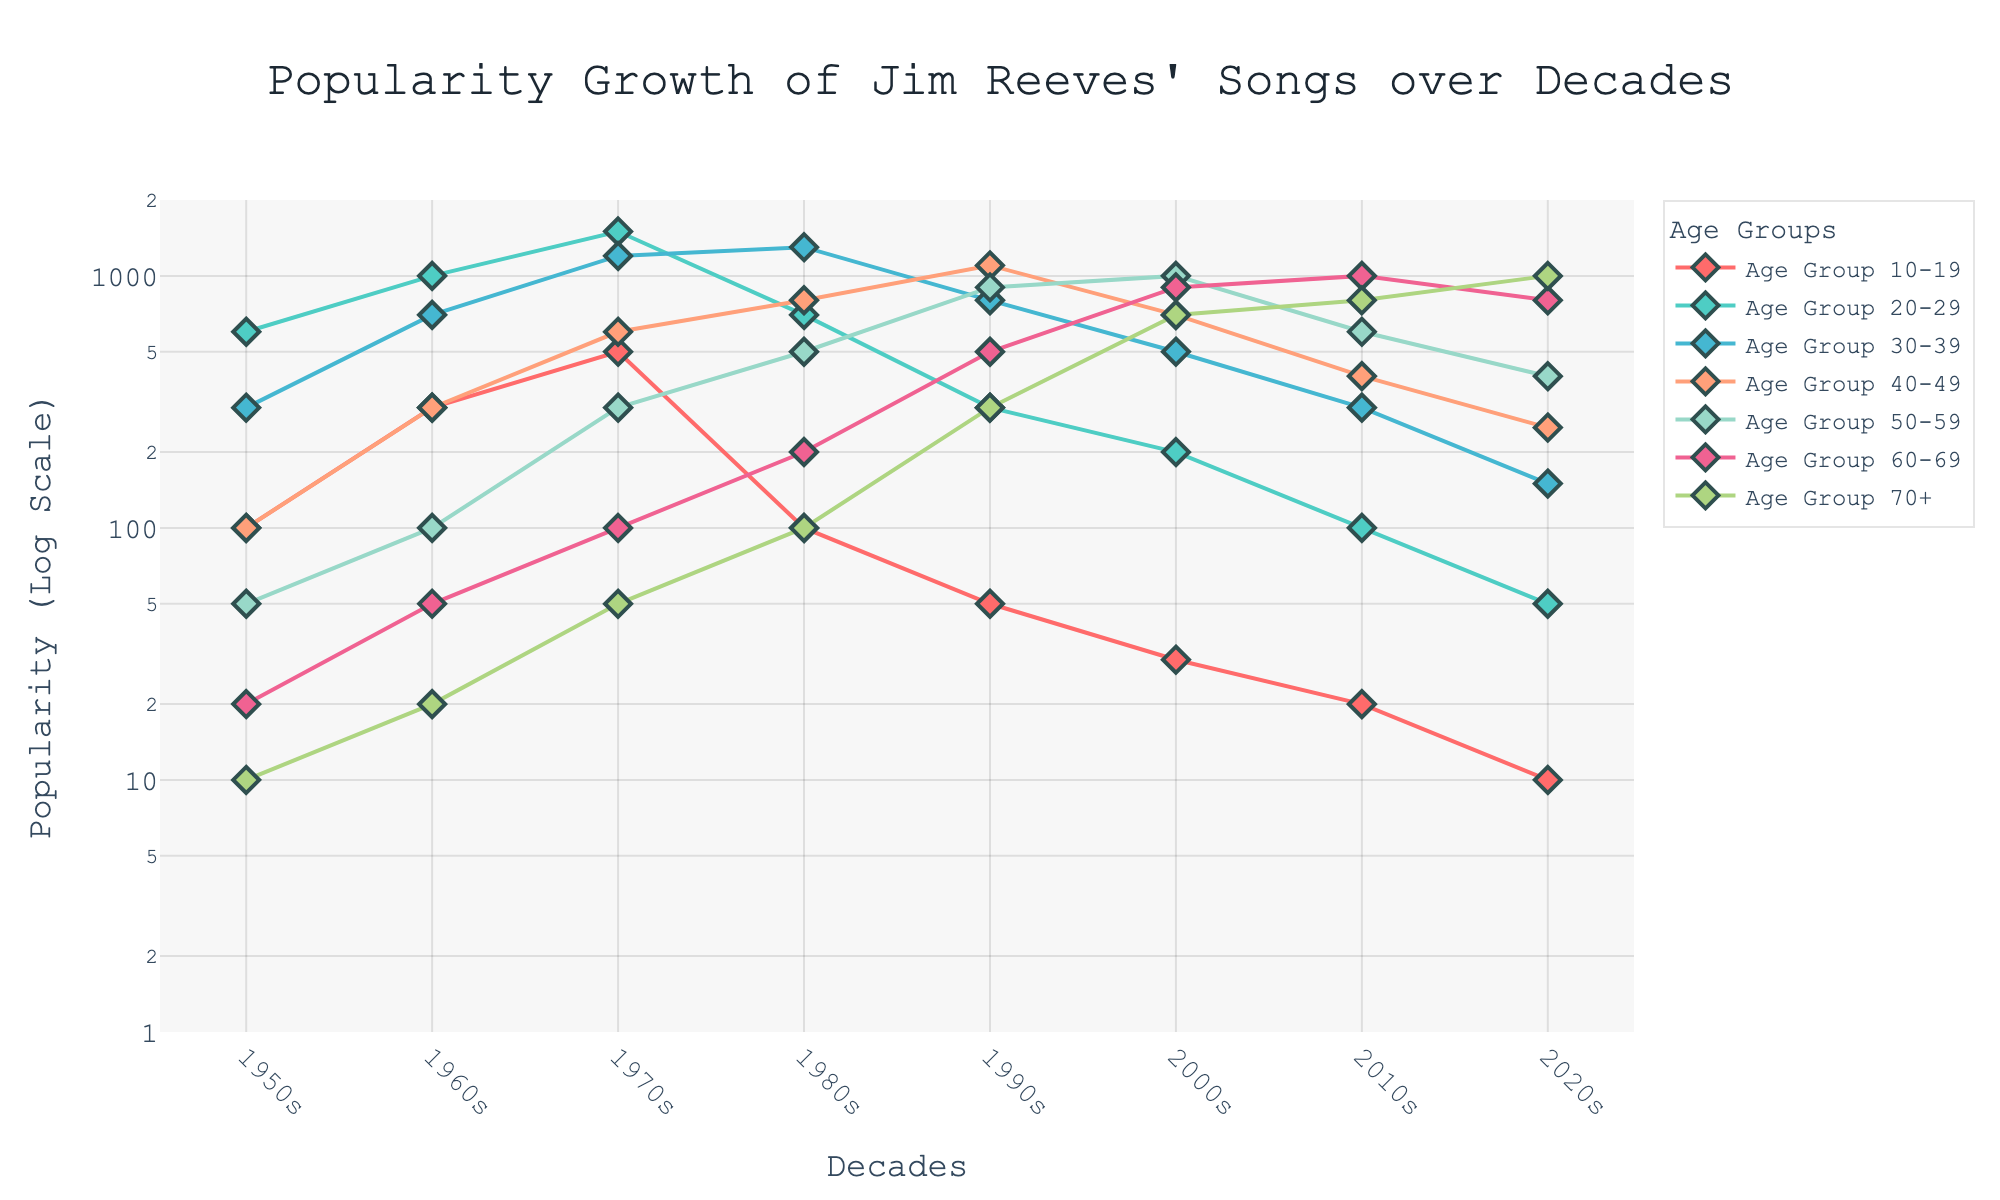What is the title of the plot? The title appears at the top of the plot and reads: "Popularity Growth of Jim Reeves' Songs over Decades".
Answer: Popularity Growth of Jim Reeves' Songs over Decades Which age group has the highest popularity in the 1960s? To find the highest popularity in the 1960s, look at the 1960s row and find the maximum value. It’s in the Age Group 20-29 with a value of 1000.
Answer: Age Group 20-29 How does the popularity trend for Age Group 40-49 change over the decades? Starting from the 1950s, the popularity values are 100, 300, 600, 800, 1100, 700, 400, and 250, initially increasing, peaking in the 1990s, and then gradually decreasing.
Answer: Increases, peaks in 1990s, then decreases Which age group shows the most consistent increase in popularity? By examining the trends for each age group over the decades, Age Group 60-69 consistently increases, with popularity values going from 20 in the 1950s to 800 in the 2020s.
Answer: Age Group 60-69 By how much did the popularity for Age Group 30-39 change from the 1970s to the 2000s? The value for the 1970s is 1200 and for the 2000s is 500. The change is 1200 - 500 = 700.
Answer: 700 Which decade saw the highest popularity for Age Group 50-59? By comparing across the decades for Age Group 50-59, the highest value is 1100 in the 1990s.
Answer: 1990s Is there any age group whose popularity decreased consistently over the decades? Analyzing the trends, Age Group 10-19 shows a consistent decrease, going from 100 in the 1950s to 10 in the 2020s.
Answer: Age Group 10-19 What is the difference in popularity between Age Group 20-29 and Age Group 30-39 in the 1970s? The value for Age Group 20-29 is 1500 and for Age Group 30-39 is 1200. The difference is 1500 - 1200 = 300.
Answer: 300 What color represents the data for Age Group 70+? By identifying from the legend, Age Group 70+ is represented by the color which is dark green.
Answer: dark green 